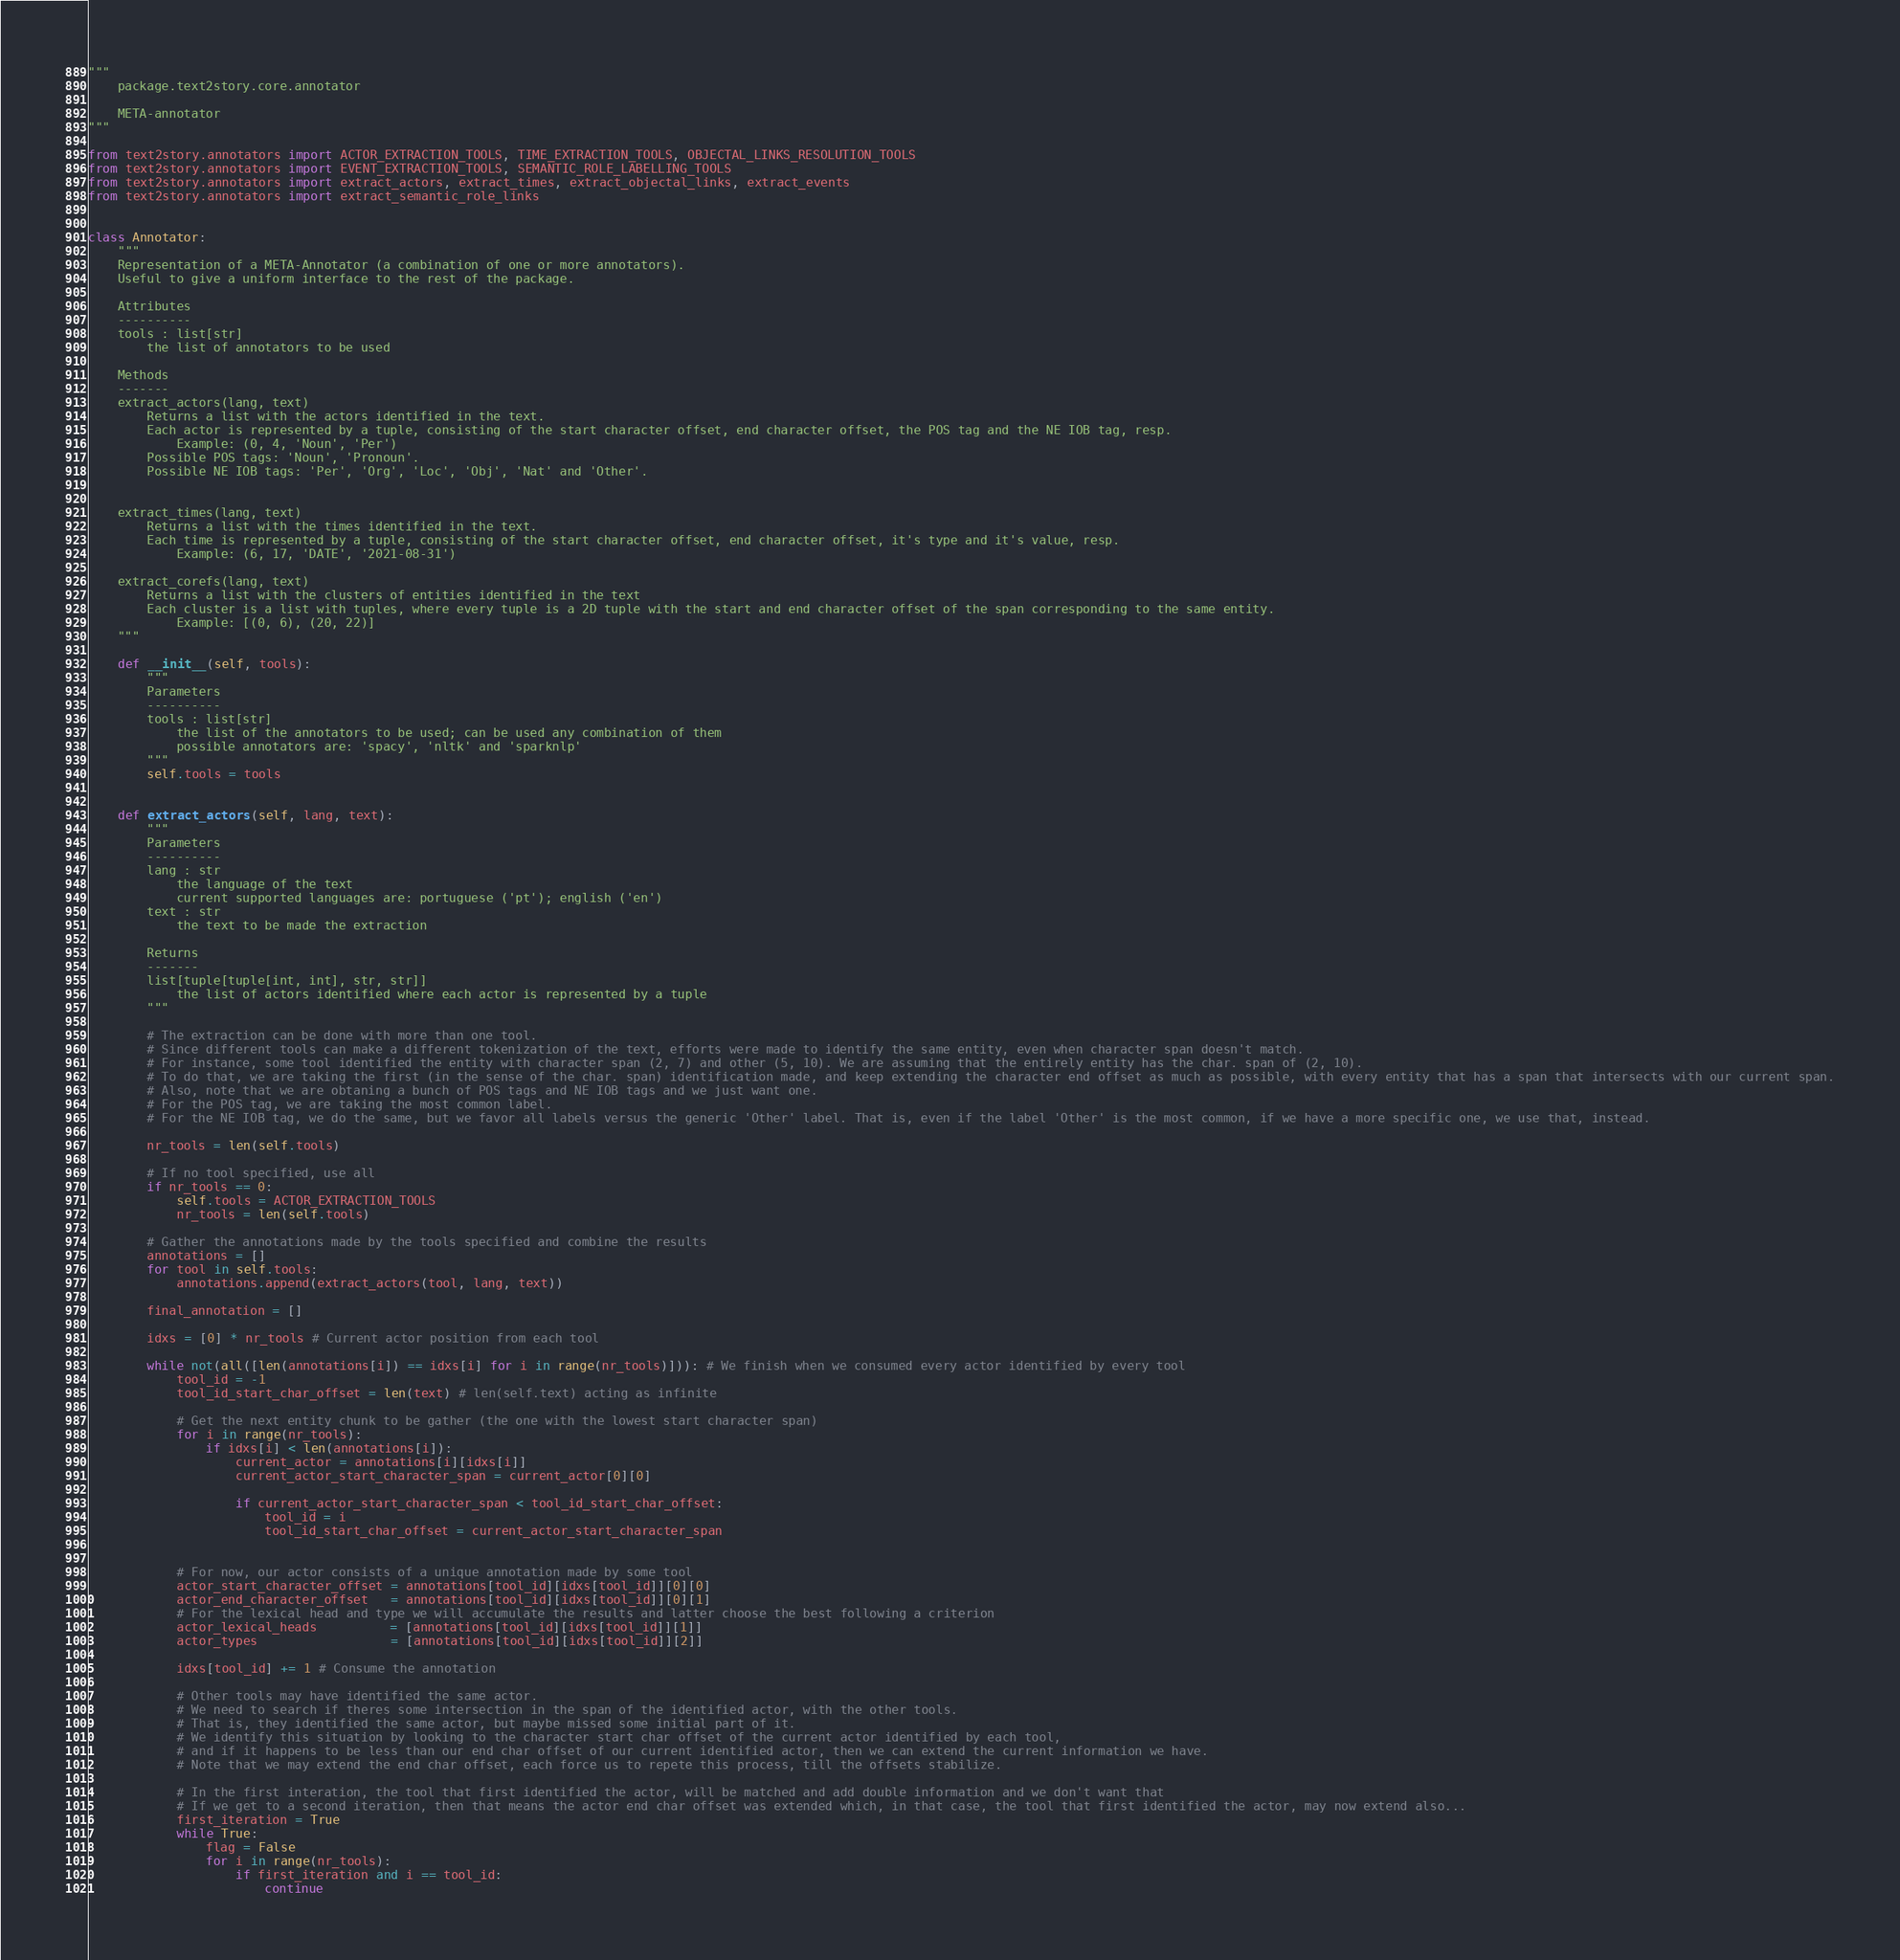<code> <loc_0><loc_0><loc_500><loc_500><_Python_>"""
	package.text2story.core.annotator

	META-annotator
"""

from text2story.annotators import ACTOR_EXTRACTION_TOOLS, TIME_EXTRACTION_TOOLS, OBJECTAL_LINKS_RESOLUTION_TOOLS
from text2story.annotators import EVENT_EXTRACTION_TOOLS, SEMANTIC_ROLE_LABELLING_TOOLS
from text2story.annotators import extract_actors, extract_times, extract_objectal_links, extract_events
from text2story.annotators import extract_semantic_role_links


class Annotator:
    """
    Representation of a META-Annotator (a combination of one or more annotators).
    Useful to give a uniform interface to the rest of the package.

    Attributes
    ----------
    tools : list[str]
        the list of annotators to be used

    Methods
    -------
    extract_actors(lang, text)
        Returns a list with the actors identified in the text.
        Each actor is represented by a tuple, consisting of the start character offset, end character offset, the POS tag and the NE IOB tag, resp.
            Example: (0, 4, 'Noun', 'Per')
        Possible POS tags: 'Noun', 'Pronoun'.
        Possible NE IOB tags: 'Per', 'Org', 'Loc', 'Obj', 'Nat' and 'Other'.


    extract_times(lang, text)
        Returns a list with the times identified in the text.
        Each time is represented by a tuple, consisting of the start character offset, end character offset, it's type and it's value, resp.
            Example: (6, 17, 'DATE', '2021-08-31')

    extract_corefs(lang, text)
        Returns a list with the clusters of entities identified in the text
        Each cluster is a list with tuples, where every tuple is a 2D tuple with the start and end character offset of the span corresponding to the same entity.
            Example: [(0, 6), (20, 22)]
    """

    def __init__(self, tools):
        """
        Parameters
        ----------
        tools : list[str]
            the list of the annotators to be used; can be used any combination of them
            possible annotators are: 'spacy', 'nltk' and 'sparknlp'
        """
        self.tools = tools


    def extract_actors(self, lang, text):
        """
        Parameters
        ----------
        lang : str
            the language of the text
            current supported languages are: portuguese ('pt'); english ('en')
        text : str
            the text to be made the extraction

        Returns
        -------
        list[tuple[tuple[int, int], str, str]]
            the list of actors identified where each actor is represented by a tuple
        """

        # The extraction can be done with more than one tool.
        # Since different tools can make a different tokenization of the text, efforts were made to identify the same entity, even when character span doesn't match.
        # For instance, some tool identified the entity with character span (2, 7) and other (5, 10). We are assuming that the entirely entity has the char. span of (2, 10).
        # To do that, we are taking the first (in the sense of the char. span) identification made, and keep extending the character end offset as much as possible, with every entity that has a span that intersects with our current span.
        # Also, note that we are obtaning a bunch of POS tags and NE IOB tags and we just want one.
        # For the POS tag, we are taking the most common label.
        # For the NE IOB tag, we do the same, but we favor all labels versus the generic 'Other' label. That is, even if the label 'Other' is the most common, if we have a more specific one, we use that, instead.

        nr_tools = len(self.tools)

        # If no tool specified, use all
        if nr_tools == 0:
            self.tools = ACTOR_EXTRACTION_TOOLS
            nr_tools = len(self.tools)

        # Gather the annotations made by the tools specified and combine the results
        annotations = []
        for tool in self.tools:
            annotations.append(extract_actors(tool, lang, text))

        final_annotation = []

        idxs = [0] * nr_tools # Current actor position from each tool

        while not(all([len(annotations[i]) == idxs[i] for i in range(nr_tools)])): # We finish when we consumed every actor identified by every tool
            tool_id = -1
            tool_id_start_char_offset = len(text) # len(self.text) acting as infinite

            # Get the next entity chunk to be gather (the one with the lowest start character span)
            for i in range(nr_tools):
                if idxs[i] < len(annotations[i]):
                    current_actor = annotations[i][idxs[i]]
                    current_actor_start_character_span = current_actor[0][0]

                    if current_actor_start_character_span < tool_id_start_char_offset:
                        tool_id = i
                        tool_id_start_char_offset = current_actor_start_character_span


            # For now, our actor consists of a unique annotation made by some tool
            actor_start_character_offset = annotations[tool_id][idxs[tool_id]][0][0]
            actor_end_character_offset   = annotations[tool_id][idxs[tool_id]][0][1]
            # For the lexical head and type we will accumulate the results and latter choose the best following a criterion
            actor_lexical_heads          = [annotations[tool_id][idxs[tool_id]][1]]
            actor_types                  = [annotations[tool_id][idxs[tool_id]][2]]

            idxs[tool_id] += 1 # Consume the annotation

            # Other tools may have identified the same actor.
            # We need to search if theres some intersection in the span of the identified actor, with the other tools.
            # That is, they identified the same actor, but maybe missed some initial part of it.
            # We identify this situation by looking to the character start char offset of the current actor identified by each tool,
            # and if it happens to be less than our end char offset of our current identified actor, then we can extend the current information we have.
            # Note that we may extend the end char offset, each force us to repete this process, till the offsets stabilize.

            # In the first interation, the tool that first identified the actor, will be matched and add double information and we don't want that
            # If we get to a second iteration, then that means the actor end char offset was extended which, in that case, the tool that first identified the actor, may now extend also...
            first_iteration = True
            while True:
                flag = False
                for i in range(nr_tools):
                    if first_iteration and i == tool_id:
                        continue
</code> 